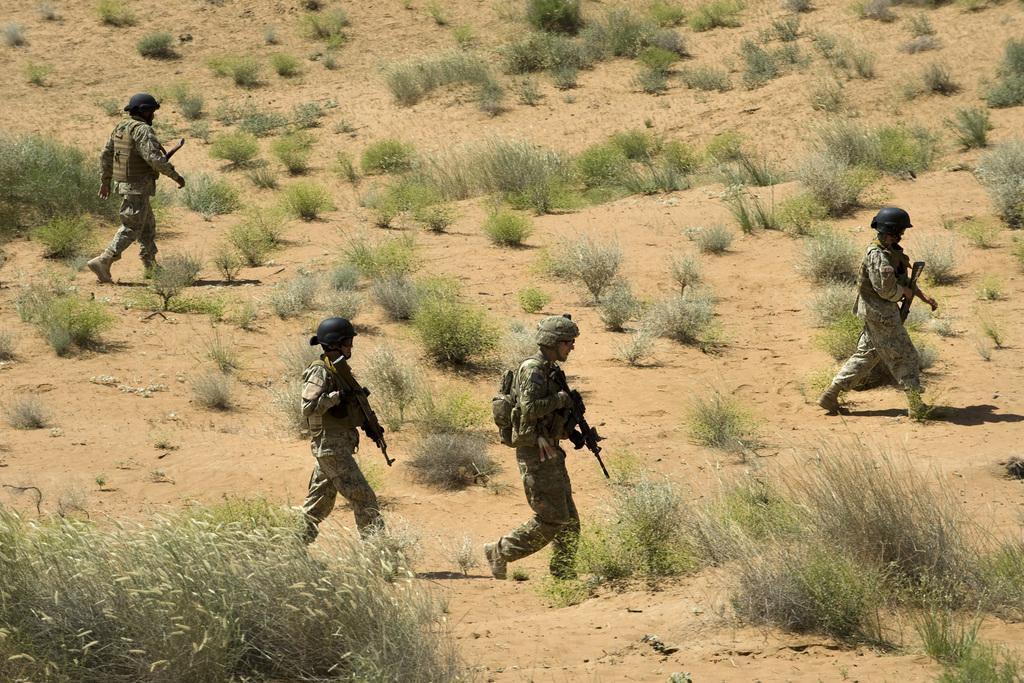Who or what can be seen in the image? There are people in the image. What are the people doing in the image? The people are walking and holding guns. What protective gear are the people wearing in the image? The people are wearing helmets. What type of natural environment is visible in the image? There is grass and plants visible in the image. Can you tell me how many icicles are hanging from the helmets in the image? There are no icicles present in the image; the people are wearing helmets, but there are no icicles hanging from them. What type of arm is visible in the image? There is no specific arm mentioned or visible in the image; the focus is on the people, their actions, and their protective gear. 